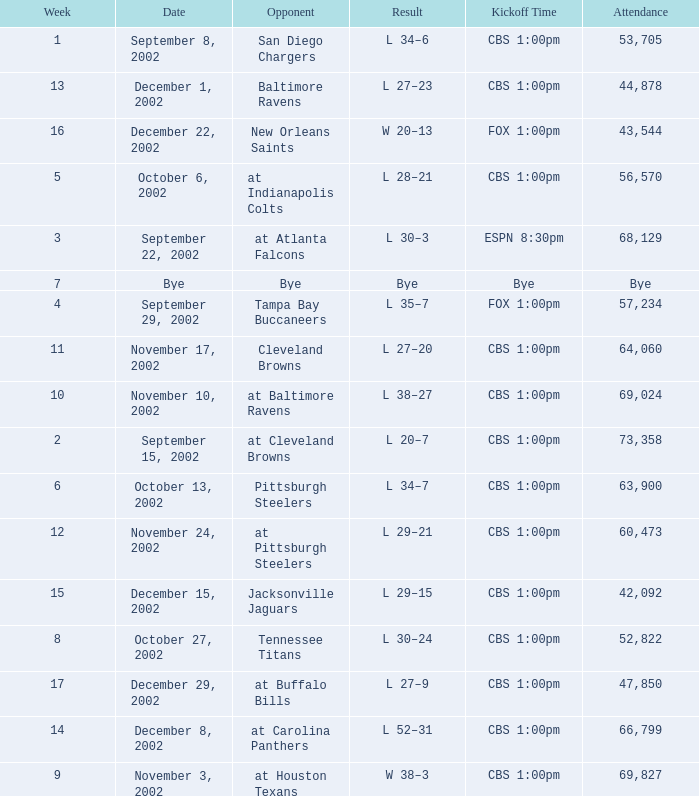What week was the opponent the San Diego Chargers? 1.0. 